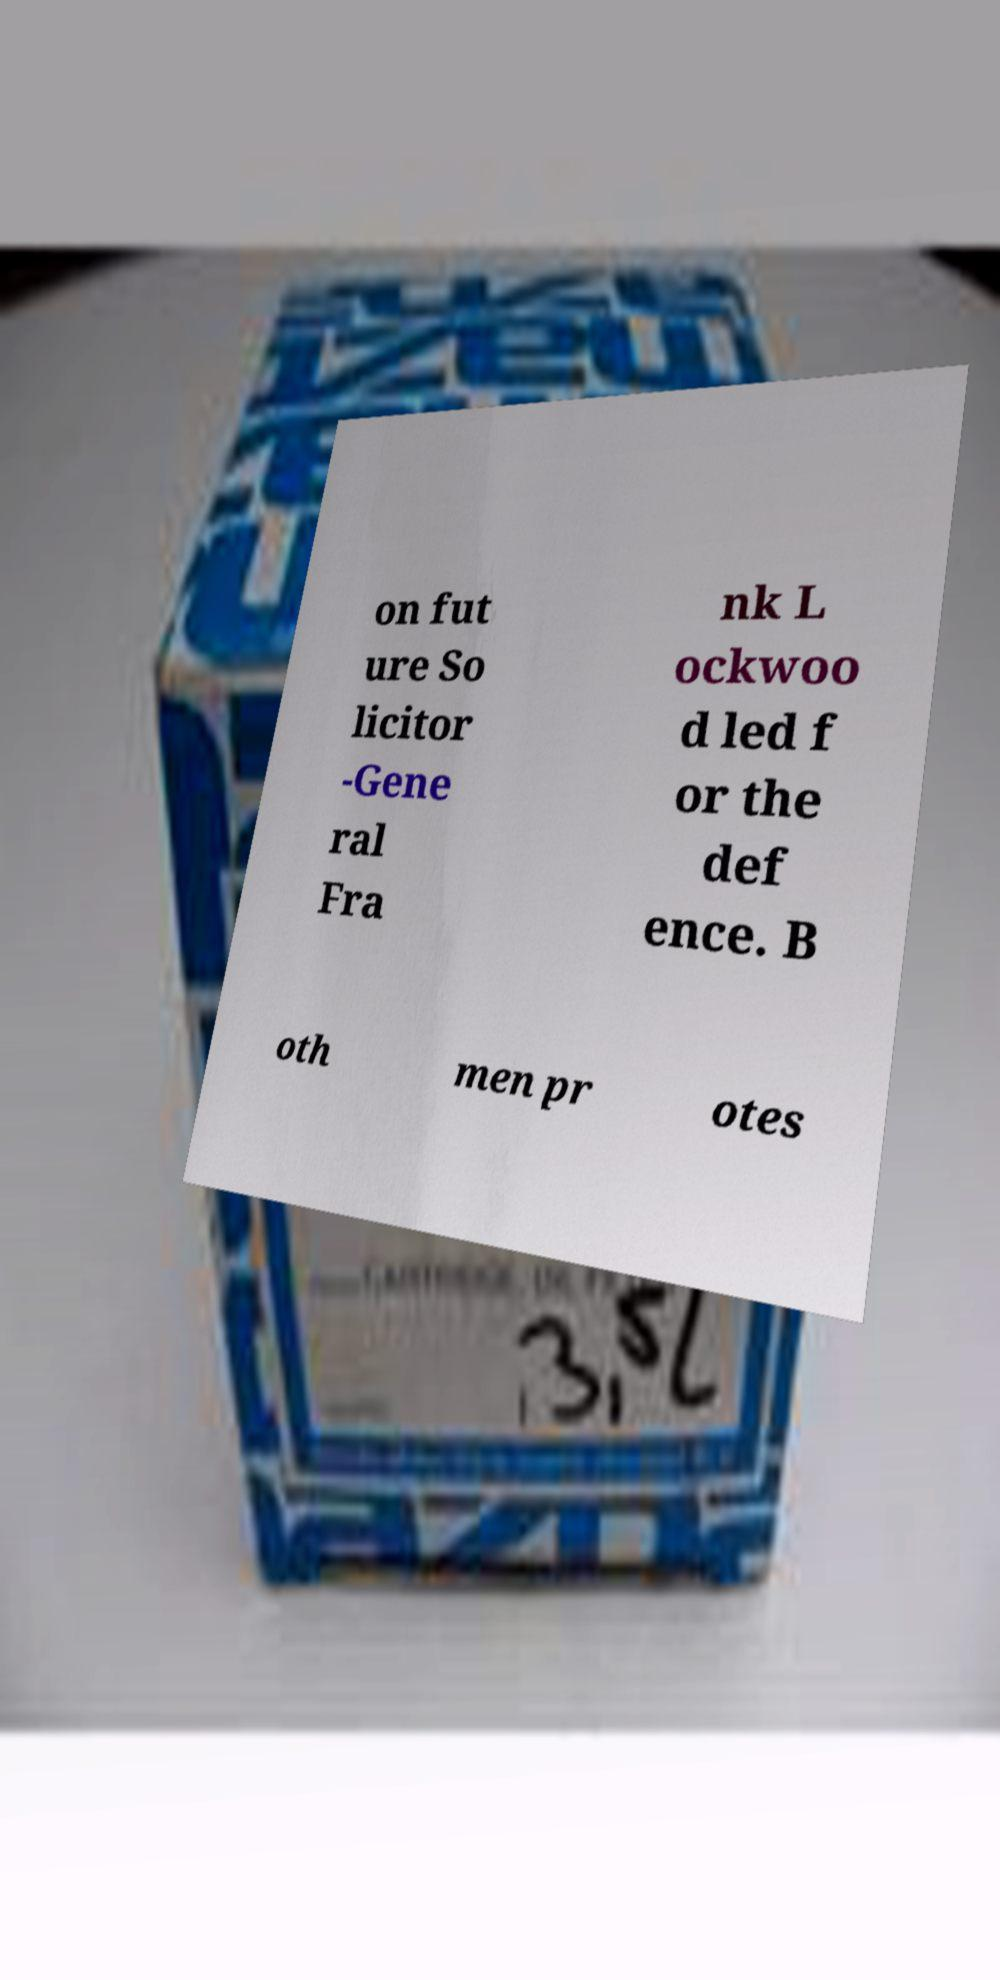There's text embedded in this image that I need extracted. Can you transcribe it verbatim? on fut ure So licitor -Gene ral Fra nk L ockwoo d led f or the def ence. B oth men pr otes 